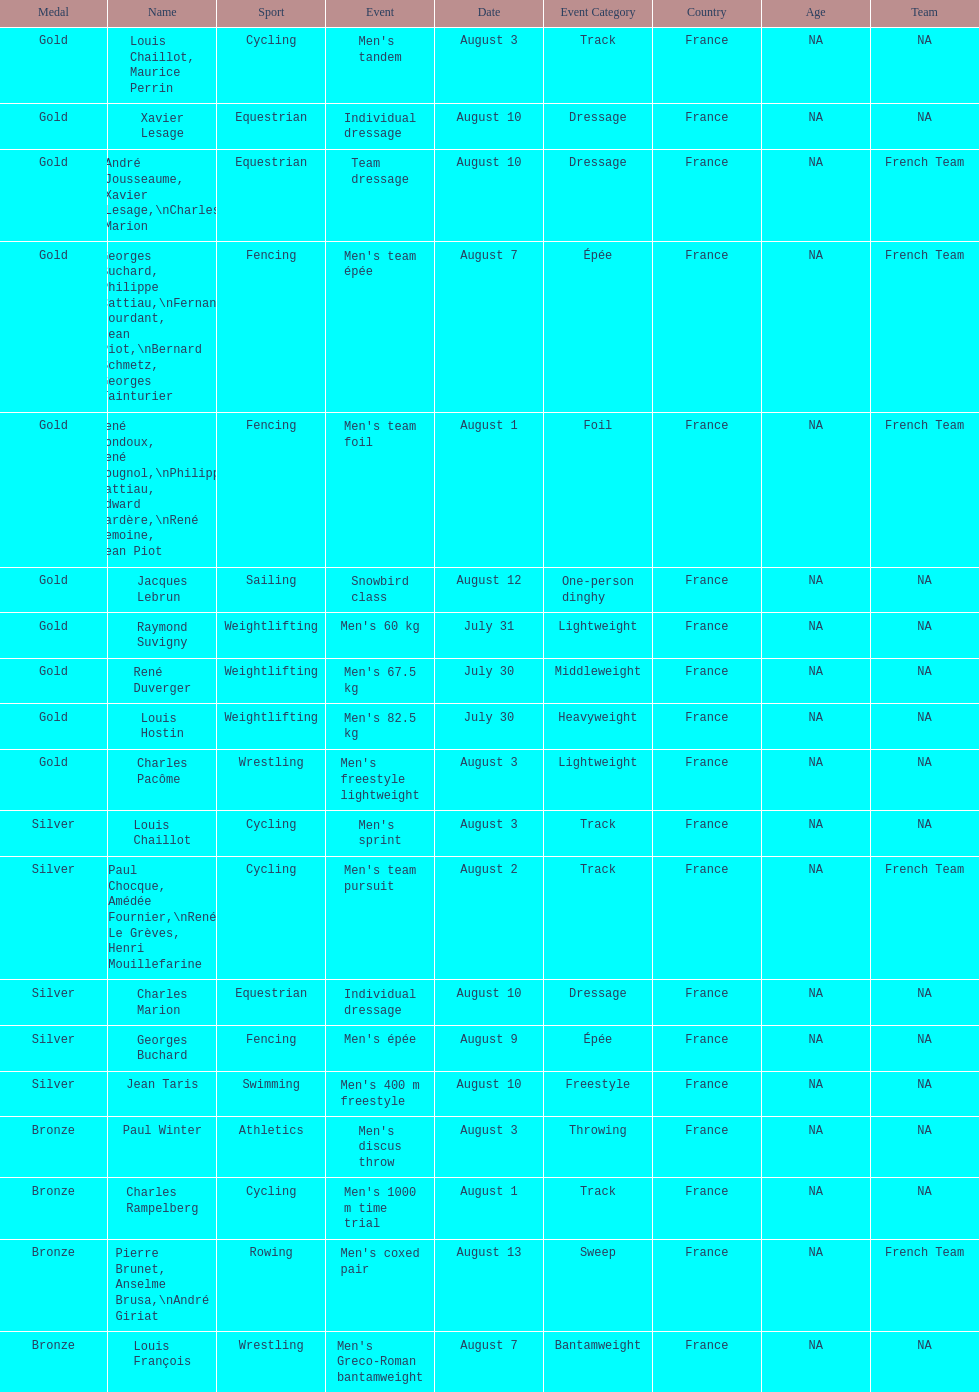How many medals were won after august 3? 9. 